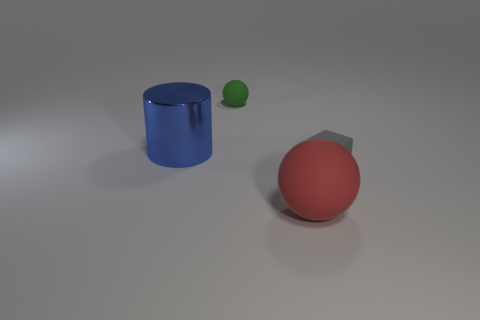Is there any other thing that has the same shape as the small gray thing?
Your answer should be very brief. No. How many tiny objects are either shiny cylinders or green matte cylinders?
Ensure brevity in your answer.  0. There is a thing that is both right of the green matte object and behind the large red ball; what material is it made of?
Your response must be concise. Rubber. There is a tiny rubber object left of the cube; is it the same shape as the thing in front of the tiny cube?
Your answer should be compact. Yes. What number of objects are either objects that are to the left of the gray matte thing or rubber cubes?
Provide a succinct answer. 4. Does the blue metal cylinder have the same size as the gray cube?
Keep it short and to the point. No. There is a matte thing in front of the gray rubber thing; what color is it?
Keep it short and to the point. Red. What size is the green thing that is made of the same material as the small gray cube?
Ensure brevity in your answer.  Small. Do the green matte ball and the rubber ball that is in front of the large cylinder have the same size?
Make the answer very short. No. There is a small thing left of the block; what material is it?
Keep it short and to the point. Rubber. 